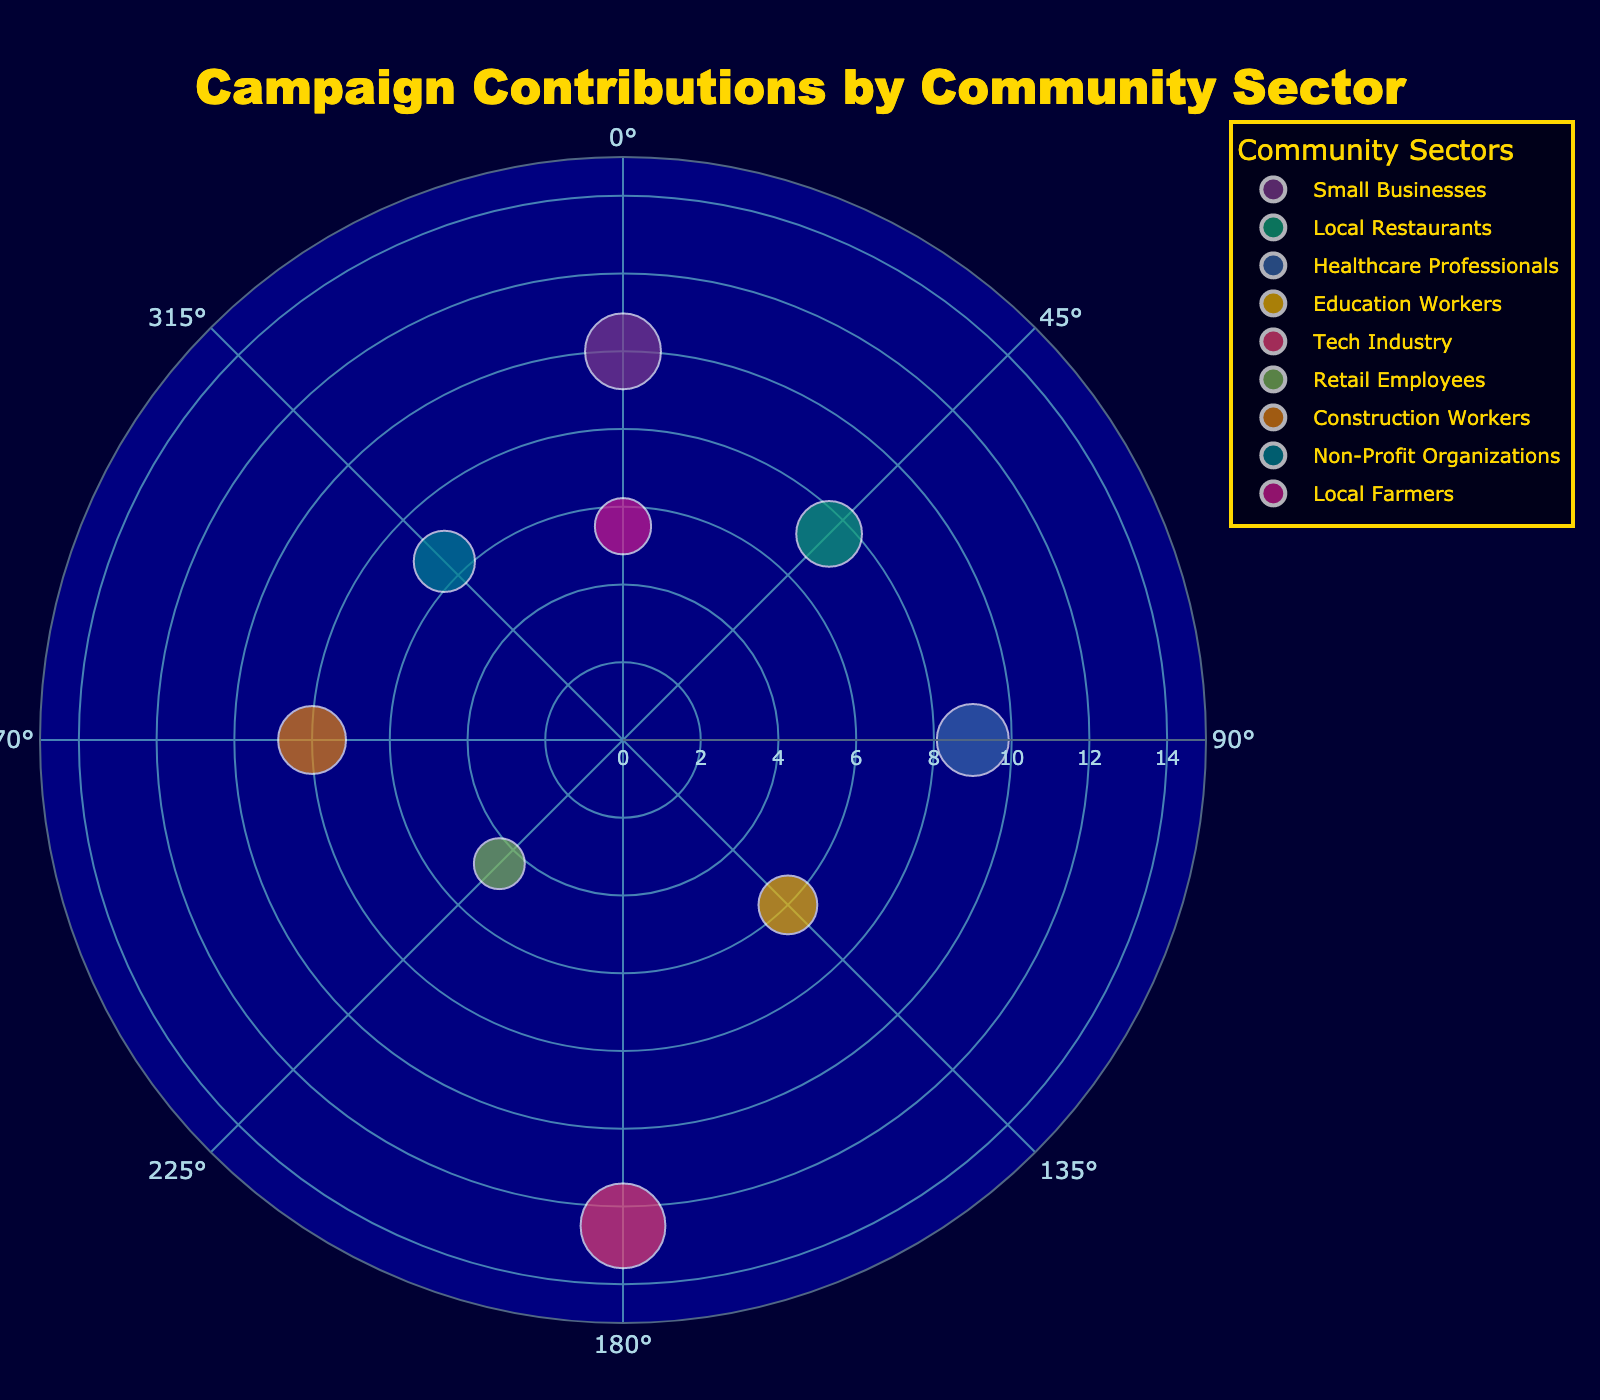What's the largest contribution amount, and which community sector made it? The largest circle represents the largest contribution, and from the plot, the largest circle is associated with the 'Tech Industry' sector. According to the data, the amount is $2500
Answer: $2500, Tech Industry How many community sectors have contributions larger than $1500? By examining the sizes of circles in the plot and referring to the data, contributions larger than $1500 are from 'Small Businesses', 'Healthcare Professionals', 'Tech Industry', 'Local Restaurants', and 'Construction Workers'. Counting these sectors, we identify 5 sectors.
Answer: 5 Which community sector is at a 90-degree angle, and what is its contribution amount? Looking at the plot, the circle at the 90-degree angle is associated with the 'Healthcare Professionals' sector. The contribution amount, according to the data, is $1800.
Answer: Healthcare Professionals, $1800 What is the total contribution amount from 'Education Workers' and 'Retail Employees'? According to the data, 'Education Workers' contributed $1200, and 'Retail Employees' contributed $900. Adding these amounts gives $1200 + $900 = $2100.
Answer: $2100 Which community sector has the smallest contribution amount, and what is this amount? Observing the smallest circle in the plot corresponds to the 'Retail Employees' sector. According to the data, the amount is $900.
Answer: Retail Employees, $900 What is the difference in contribution amounts between 'Local Restaurants' and 'Local Farmers'? From the data, 'Local Restaurants' contributed $1500 and 'Local Farmers' contributed $1100. The difference is $1500 - $1100 = $400
Answer: $400 Which community sectors have contributions represented at the 0 and 360-degree angles, respectively, and are their contribution amounts equal? From the plot, the sector at 0 degrees is 'Small Businesses' with $2000, and the sector at 360 degrees is 'Local Farmers' with $1100. Their contribution amounts are not equal; $2000 ≠ $1100
Answer: 'Small Businesses' and 'Local Farmers', No Which two community sectors have contributions closest in amount, and what is the difference between their contributions? From the data, the sectors with the closest contributions are 'Local Restaurants' ($1500) and 'Construction Workers' ($1600). The difference is $1600 - $1500 = $100
Answer: 'Local Restaurants' and 'Construction Workers', $100 